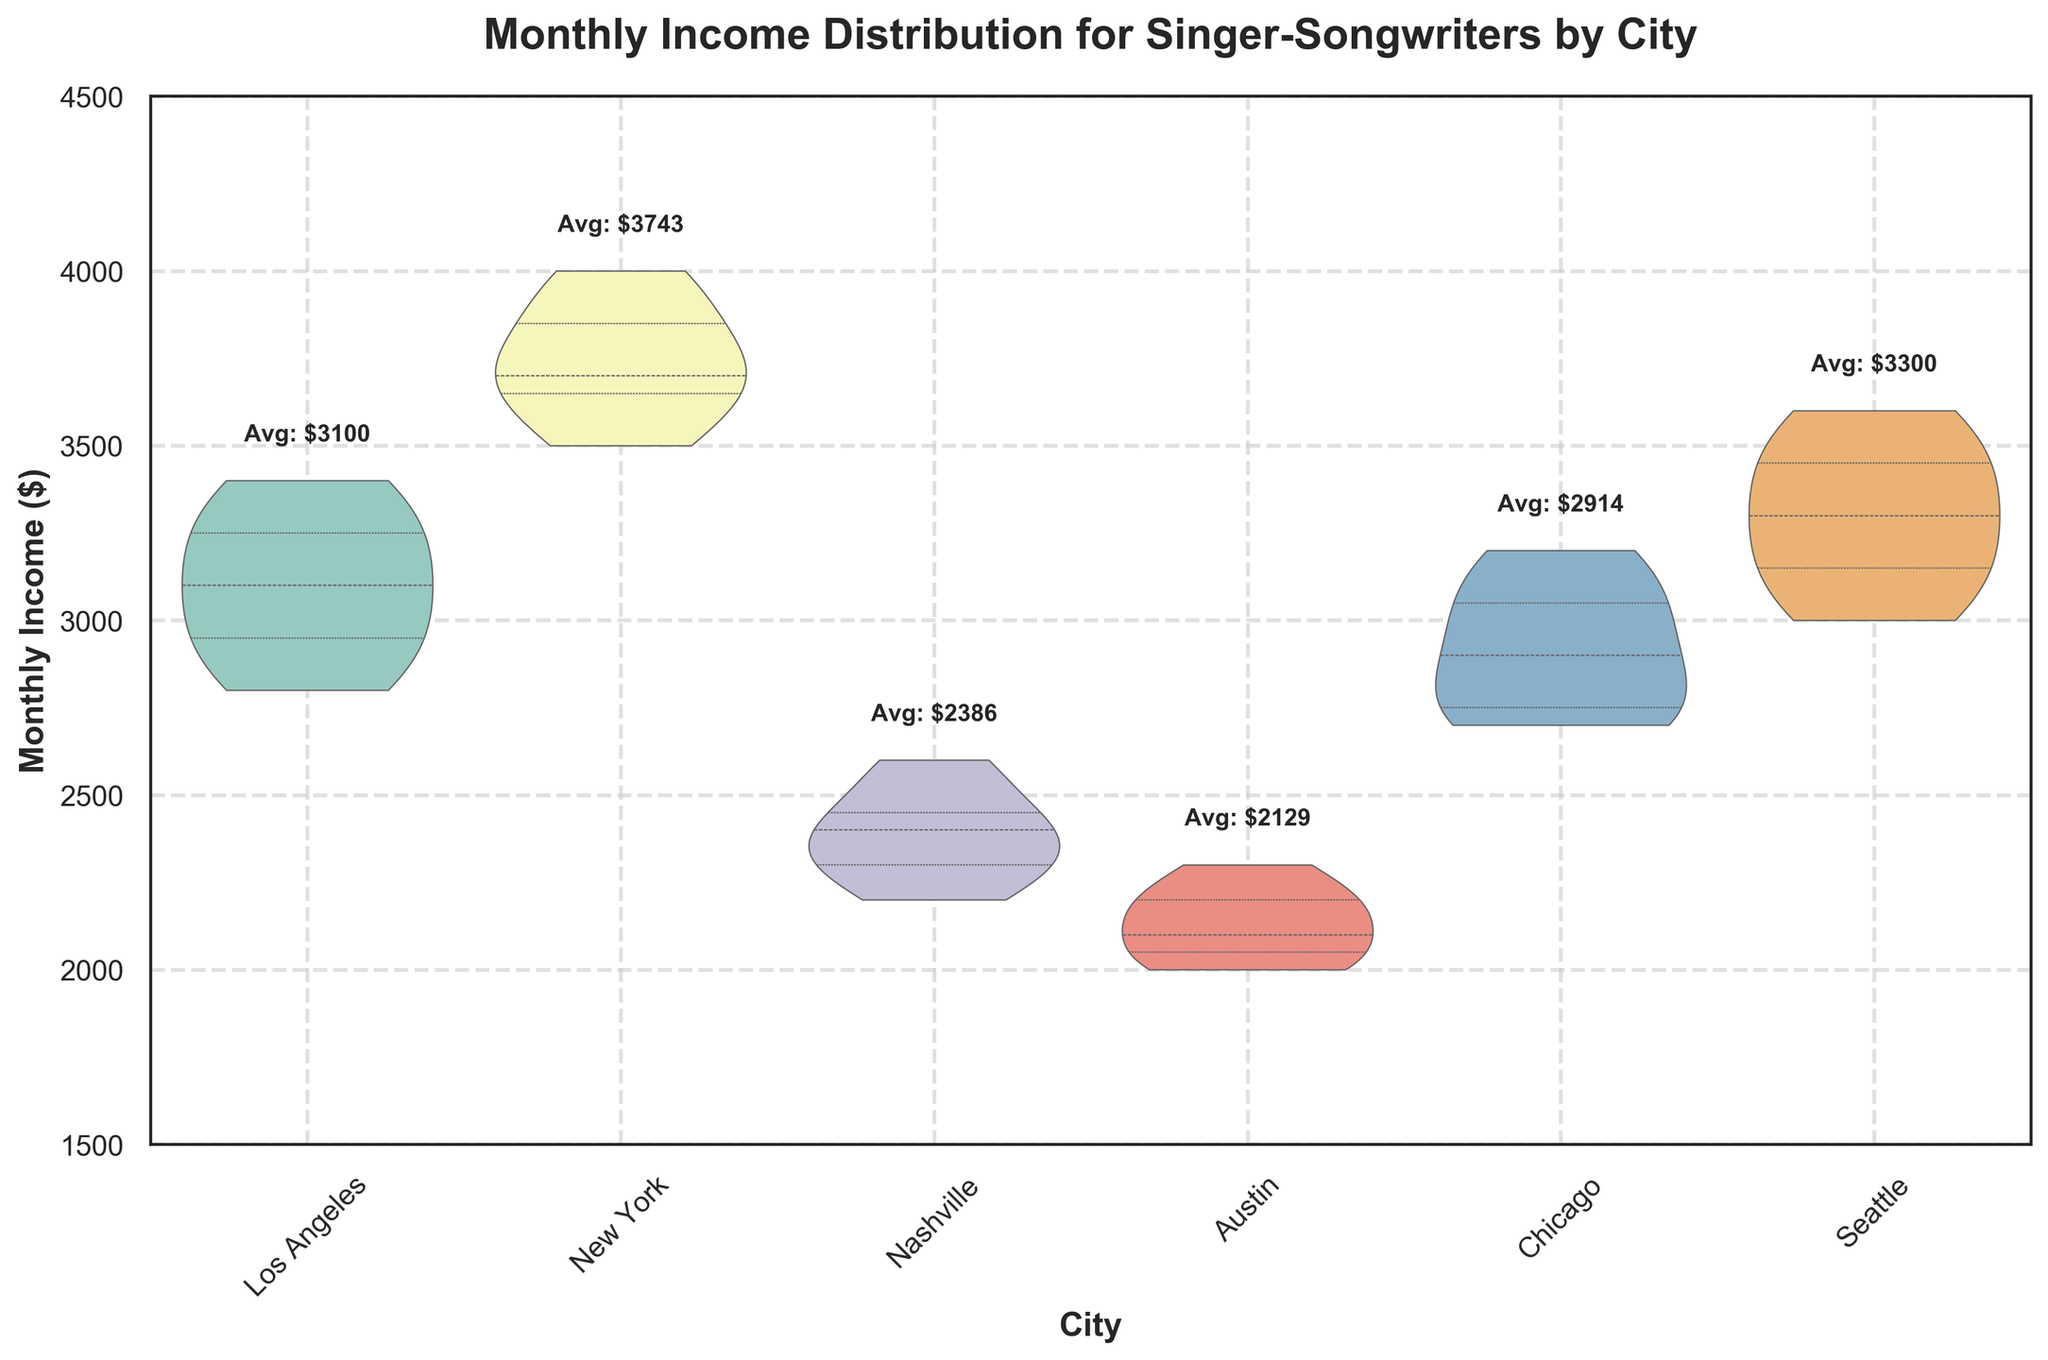What is the title of the figure? The title is visually located at the top center part of the plot and describes the main topic displayed.
Answer: Monthly Income Distribution for Singer-Songwriters by City Which city has the highest average monthly income? Each city has an annotation above its violins indicating the average monthly income. New York has "Avg: $3814".
Answer: New York What is the median monthly income for singer-songwriters in Austin? In violin plots, the median is indicated by a line inside the wider section of the violin shape. For Austin, this line is around $2100.
Answer: $2100 Which city shows the greatest variability in monthly income? The variability in a violin plot is represented by the width and spread of the violin. New York shows the widest spread, from approximately $3500 to $4000.
Answer: New York How does the income distribution in Los Angeles compare to that in Seattle? To compare, look at the overall shape and spread of the violins. Los Angeles has a narrower distribution concentrated around $3100-$3400, while Seattle shows a wider spread from $3000 to approximately $3500.
Answer: Los Angeles has a narrower distribution; Seattle has a wider spread What is the highest monthly income observed in Chicago? The highest point in the Chicago violin, as indicated visually, is around $3200.
Answer: $3200 Between Nashville and Austin, which city has a higher range of incomes? Visually, look at the length of the violins from bottom to top. Nashville's distribution ranges from $2200 to $2600, while Austin ranges from $2000 to $2300.
Answer: Nashville What do the quartile lines inside the violins represent? These lines divide the data into four equal parts, indicating where 25%, 50%, and 75% of the data lie.
Answer: Quartiles Which city shows the lowest average monthly income? Each city's average income is annotated above its respective violin. Austin has "Avg: $2133”.
Answer: Austin 